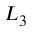Convert formula to latex. <formula><loc_0><loc_0><loc_500><loc_500>L _ { 3 }</formula> 